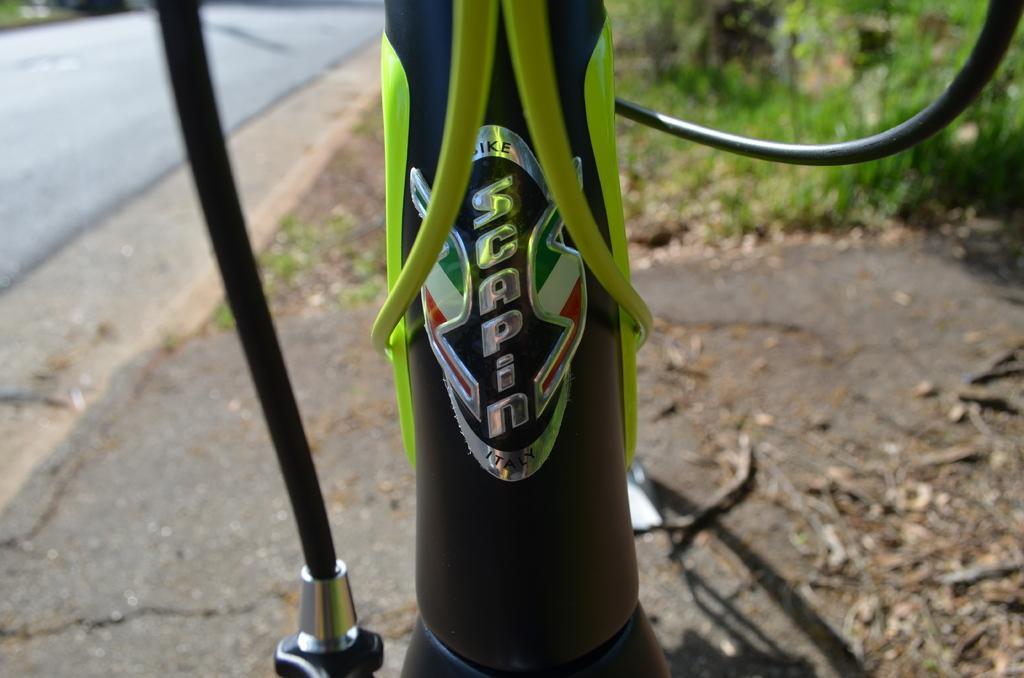In one or two sentences, can you explain what this image depicts? This is a zoomed image. In this image there is a front part of a bicycle. On the left side of the image there is a road. On the right side of the image there are trees and dry leaves on the path. 